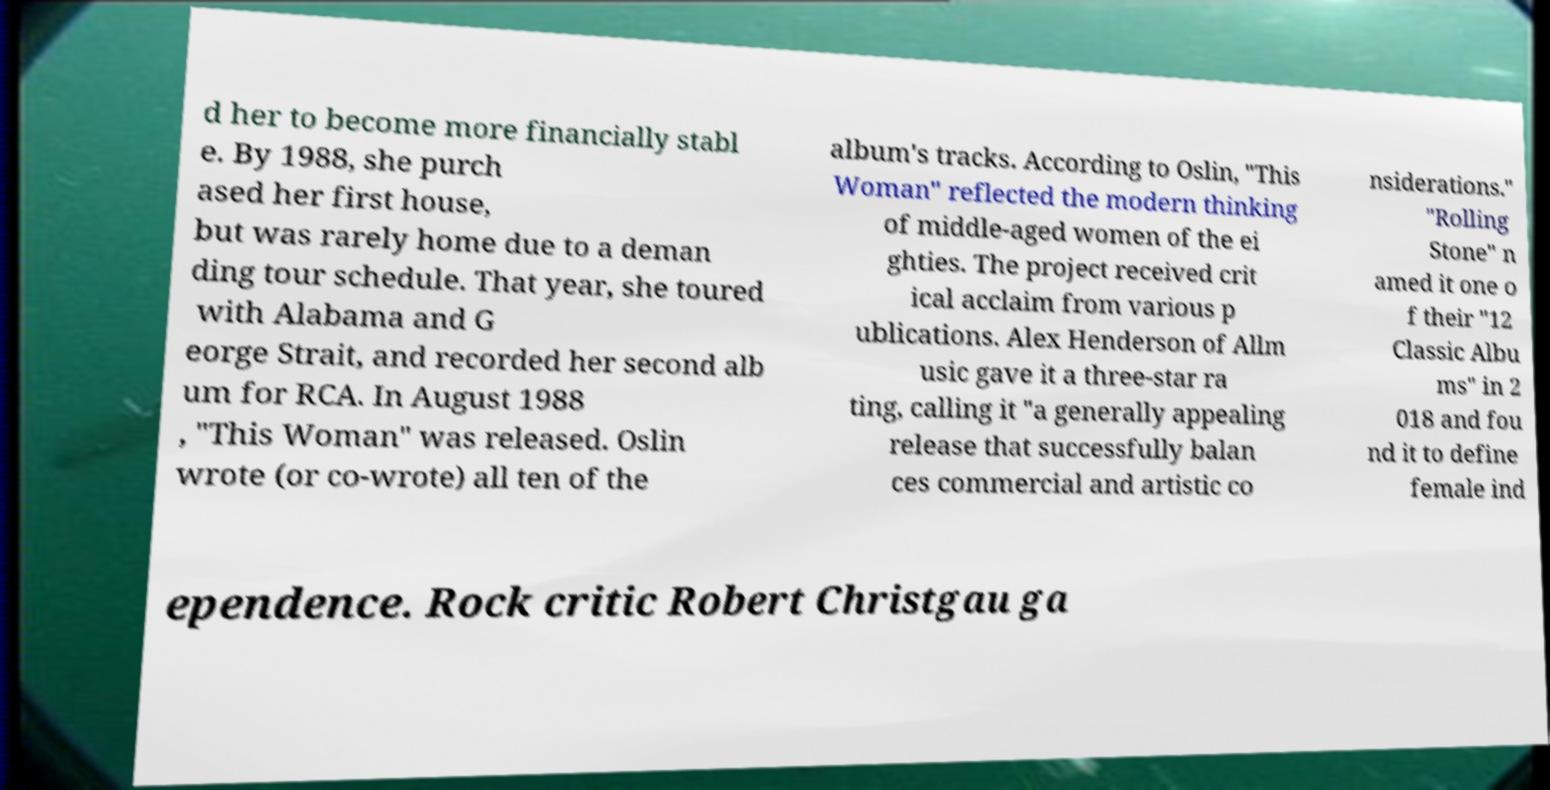Could you extract and type out the text from this image? d her to become more financially stabl e. By 1988, she purch ased her first house, but was rarely home due to a deman ding tour schedule. That year, she toured with Alabama and G eorge Strait, and recorded her second alb um for RCA. In August 1988 , "This Woman" was released. Oslin wrote (or co-wrote) all ten of the album's tracks. According to Oslin, "This Woman" reflected the modern thinking of middle-aged women of the ei ghties. The project received crit ical acclaim from various p ublications. Alex Henderson of Allm usic gave it a three-star ra ting, calling it "a generally appealing release that successfully balan ces commercial and artistic co nsiderations." "Rolling Stone" n amed it one o f their "12 Classic Albu ms" in 2 018 and fou nd it to define female ind ependence. Rock critic Robert Christgau ga 